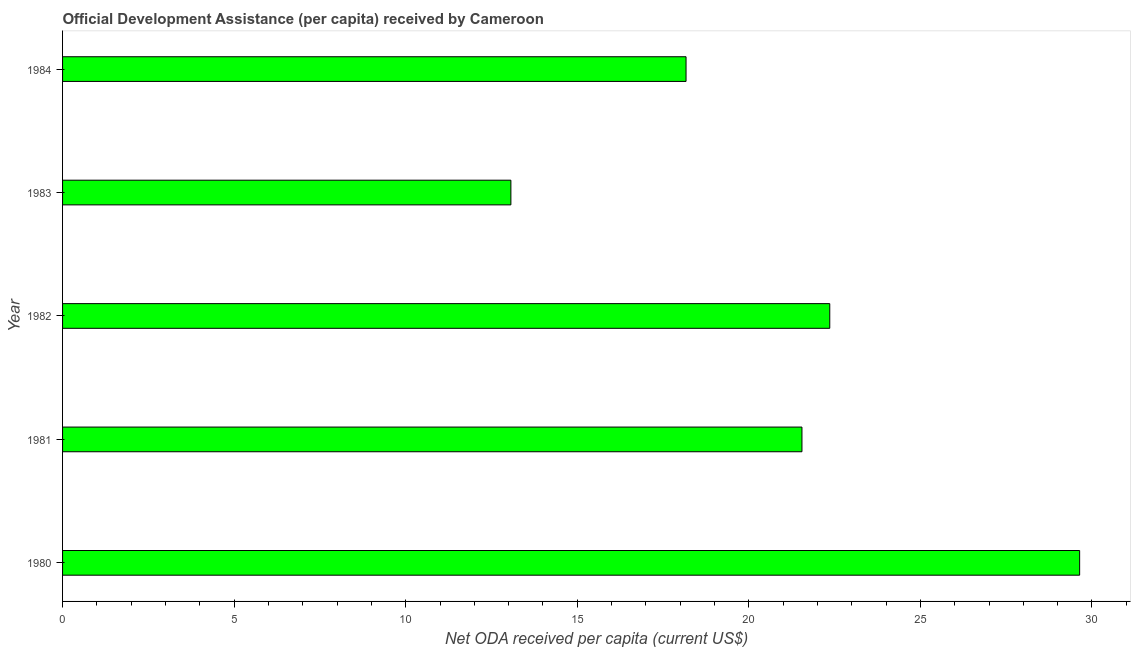What is the title of the graph?
Keep it short and to the point. Official Development Assistance (per capita) received by Cameroon. What is the label or title of the X-axis?
Your response must be concise. Net ODA received per capita (current US$). What is the label or title of the Y-axis?
Your answer should be compact. Year. What is the net oda received per capita in 1980?
Offer a very short reply. 29.64. Across all years, what is the maximum net oda received per capita?
Give a very brief answer. 29.64. Across all years, what is the minimum net oda received per capita?
Offer a very short reply. 13.07. In which year was the net oda received per capita minimum?
Ensure brevity in your answer.  1983. What is the sum of the net oda received per capita?
Keep it short and to the point. 104.79. What is the difference between the net oda received per capita in 1980 and 1983?
Ensure brevity in your answer.  16.58. What is the average net oda received per capita per year?
Offer a terse response. 20.96. What is the median net oda received per capita?
Give a very brief answer. 21.55. In how many years, is the net oda received per capita greater than 15 US$?
Provide a short and direct response. 4. What is the ratio of the net oda received per capita in 1980 to that in 1984?
Provide a succinct answer. 1.63. Is the net oda received per capita in 1980 less than that in 1982?
Your response must be concise. No. Is the difference between the net oda received per capita in 1980 and 1983 greater than the difference between any two years?
Keep it short and to the point. Yes. What is the difference between the highest and the second highest net oda received per capita?
Give a very brief answer. 7.28. What is the difference between the highest and the lowest net oda received per capita?
Keep it short and to the point. 16.58. In how many years, is the net oda received per capita greater than the average net oda received per capita taken over all years?
Offer a terse response. 3. How many bars are there?
Provide a short and direct response. 5. How many years are there in the graph?
Offer a very short reply. 5. What is the difference between two consecutive major ticks on the X-axis?
Offer a very short reply. 5. What is the Net ODA received per capita (current US$) of 1980?
Your response must be concise. 29.64. What is the Net ODA received per capita (current US$) in 1981?
Your answer should be compact. 21.55. What is the Net ODA received per capita (current US$) in 1982?
Offer a very short reply. 22.36. What is the Net ODA received per capita (current US$) of 1983?
Provide a succinct answer. 13.07. What is the Net ODA received per capita (current US$) of 1984?
Keep it short and to the point. 18.17. What is the difference between the Net ODA received per capita (current US$) in 1980 and 1981?
Give a very brief answer. 8.09. What is the difference between the Net ODA received per capita (current US$) in 1980 and 1982?
Offer a terse response. 7.28. What is the difference between the Net ODA received per capita (current US$) in 1980 and 1983?
Give a very brief answer. 16.58. What is the difference between the Net ODA received per capita (current US$) in 1980 and 1984?
Provide a succinct answer. 11.47. What is the difference between the Net ODA received per capita (current US$) in 1981 and 1982?
Your response must be concise. -0.81. What is the difference between the Net ODA received per capita (current US$) in 1981 and 1983?
Your response must be concise. 8.48. What is the difference between the Net ODA received per capita (current US$) in 1981 and 1984?
Keep it short and to the point. 3.38. What is the difference between the Net ODA received per capita (current US$) in 1982 and 1983?
Your response must be concise. 9.29. What is the difference between the Net ODA received per capita (current US$) in 1982 and 1984?
Keep it short and to the point. 4.19. What is the difference between the Net ODA received per capita (current US$) in 1983 and 1984?
Provide a succinct answer. -5.1. What is the ratio of the Net ODA received per capita (current US$) in 1980 to that in 1981?
Keep it short and to the point. 1.38. What is the ratio of the Net ODA received per capita (current US$) in 1980 to that in 1982?
Offer a very short reply. 1.33. What is the ratio of the Net ODA received per capita (current US$) in 1980 to that in 1983?
Ensure brevity in your answer.  2.27. What is the ratio of the Net ODA received per capita (current US$) in 1980 to that in 1984?
Give a very brief answer. 1.63. What is the ratio of the Net ODA received per capita (current US$) in 1981 to that in 1983?
Make the answer very short. 1.65. What is the ratio of the Net ODA received per capita (current US$) in 1981 to that in 1984?
Provide a short and direct response. 1.19. What is the ratio of the Net ODA received per capita (current US$) in 1982 to that in 1983?
Provide a succinct answer. 1.71. What is the ratio of the Net ODA received per capita (current US$) in 1982 to that in 1984?
Keep it short and to the point. 1.23. What is the ratio of the Net ODA received per capita (current US$) in 1983 to that in 1984?
Ensure brevity in your answer.  0.72. 